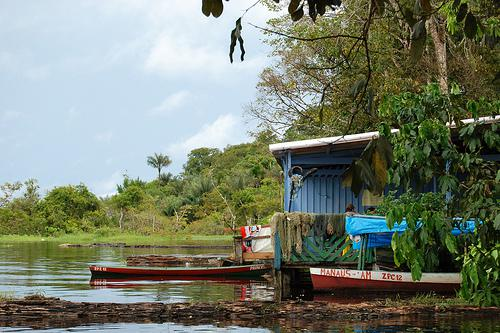Question: what color is the boat house?
Choices:
A. White.
B. Blue.
C. Red.
D. Yellow.
Answer with the letter. Answer: B Question: what color are the trees?
Choices:
A. Red.
B. Green.
C. Yellow.
D. Brown.
Answer with the letter. Answer: B Question: why are the boats docked?
Choices:
A. To repair.
B. To load.
C. No one is in them.
D. To paint.
Answer with the letter. Answer: C Question: who is in the boats?
Choices:
A. The painters.
B. The repair people.
C. The men.
D. There isn't anyone on the boats.
Answer with the letter. Answer: D 